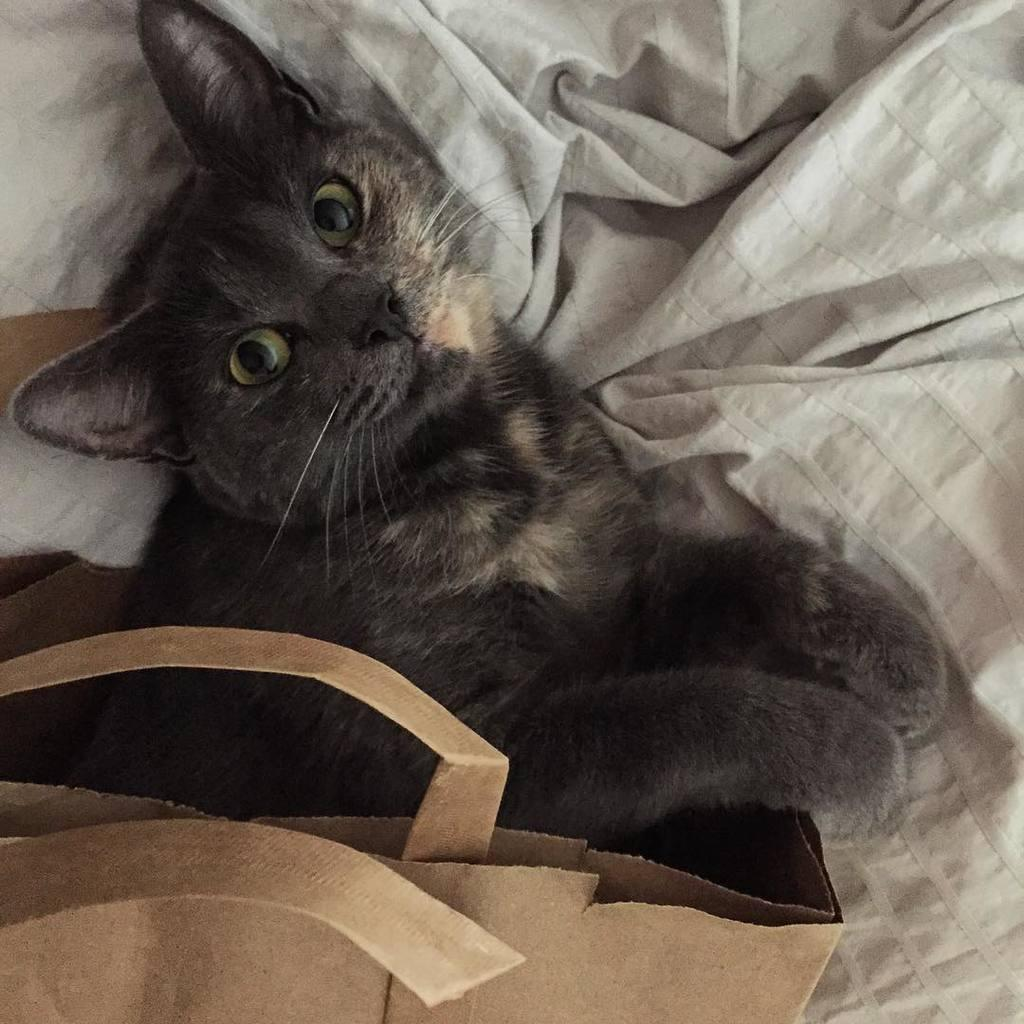What type of animal is in the image? There is a cat in the image. What is the cat lying on? The cat is lying on a blanket. What else can be seen in the image besides the cat? There is a bag in the image. What type of throat condition does the cat have in the image? There is no indication of any throat condition in the image; the cat appears to be healthy and resting on a blanket. 